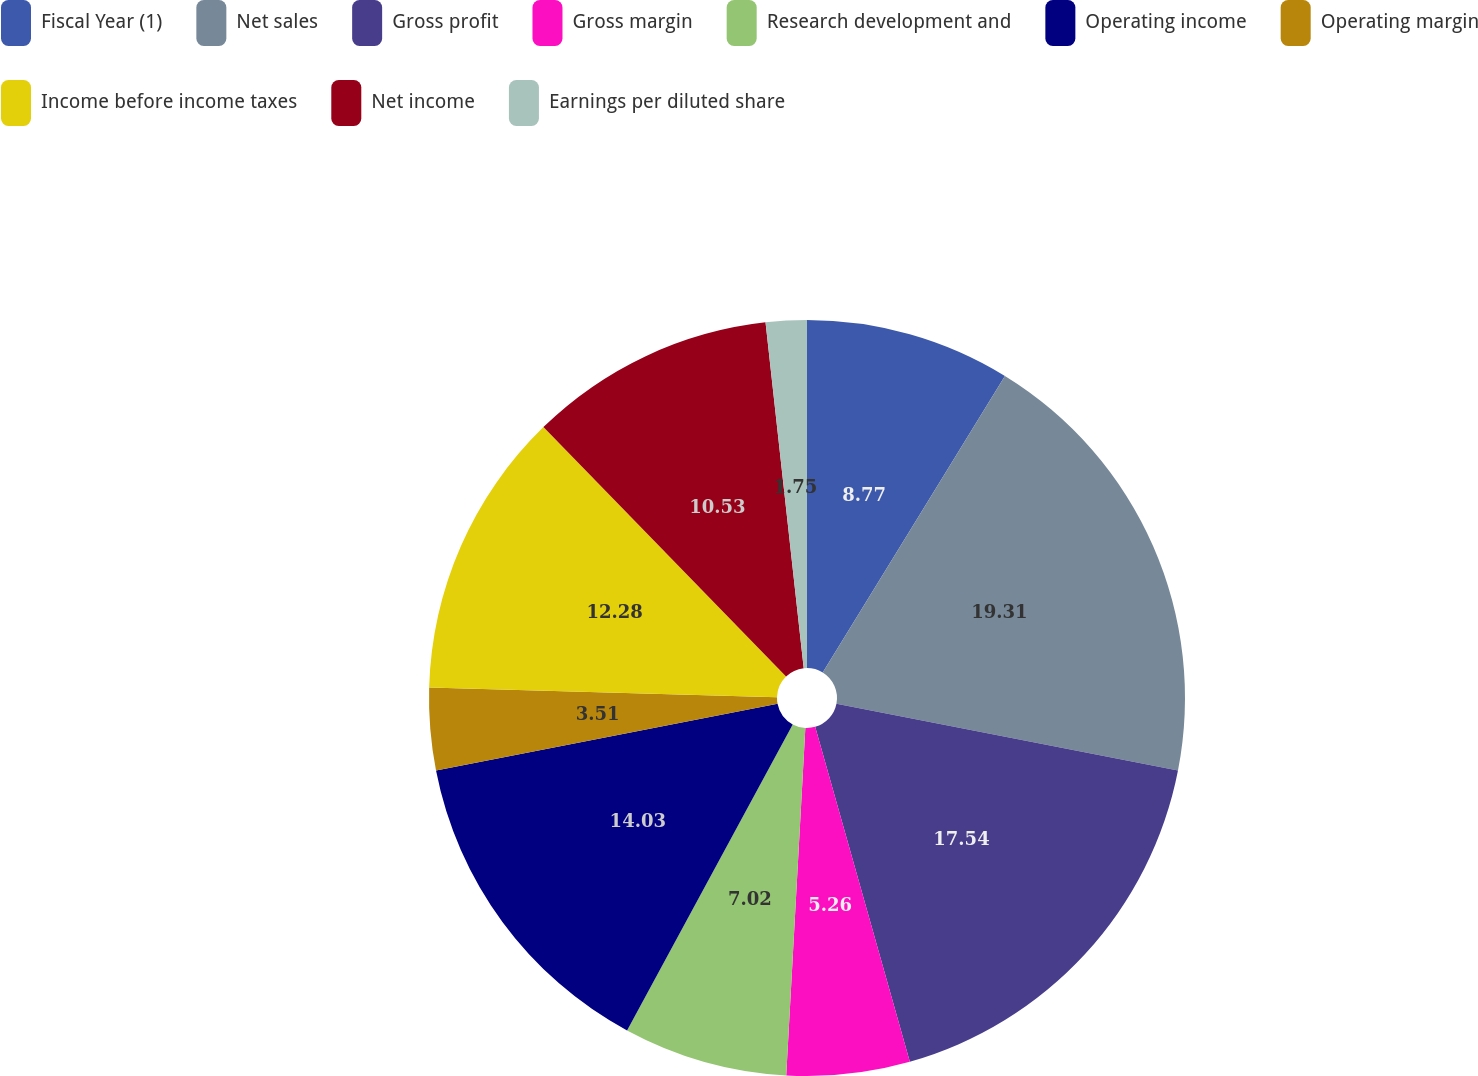Convert chart. <chart><loc_0><loc_0><loc_500><loc_500><pie_chart><fcel>Fiscal Year (1)<fcel>Net sales<fcel>Gross profit<fcel>Gross margin<fcel>Research development and<fcel>Operating income<fcel>Operating margin<fcel>Income before income taxes<fcel>Net income<fcel>Earnings per diluted share<nl><fcel>8.77%<fcel>19.3%<fcel>17.54%<fcel>5.26%<fcel>7.02%<fcel>14.03%<fcel>3.51%<fcel>12.28%<fcel>10.53%<fcel>1.75%<nl></chart> 